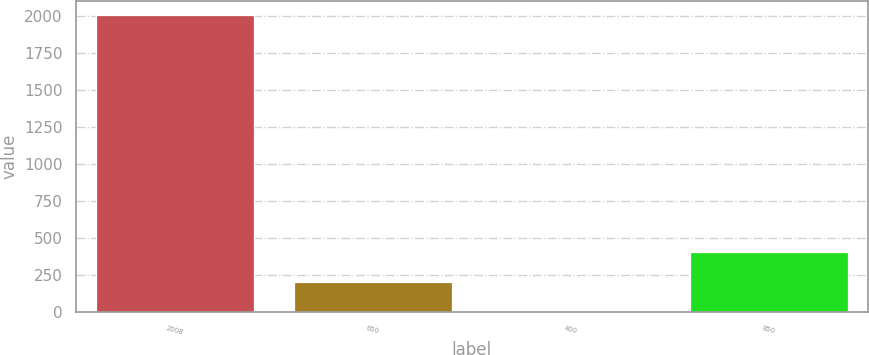Convert chart. <chart><loc_0><loc_0><loc_500><loc_500><bar_chart><fcel>2008<fcel>650<fcel>400<fcel>850<nl><fcel>2007<fcel>204.3<fcel>4<fcel>404.6<nl></chart> 